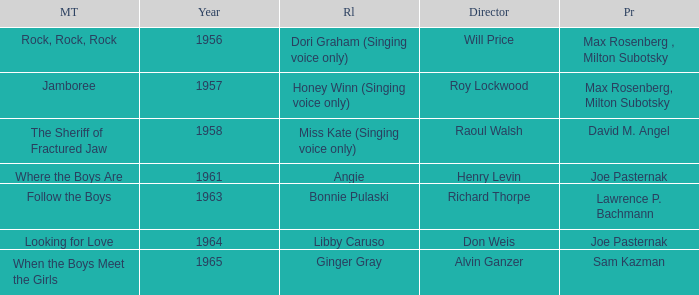Who were the producers in 1961? Joe Pasternak. 